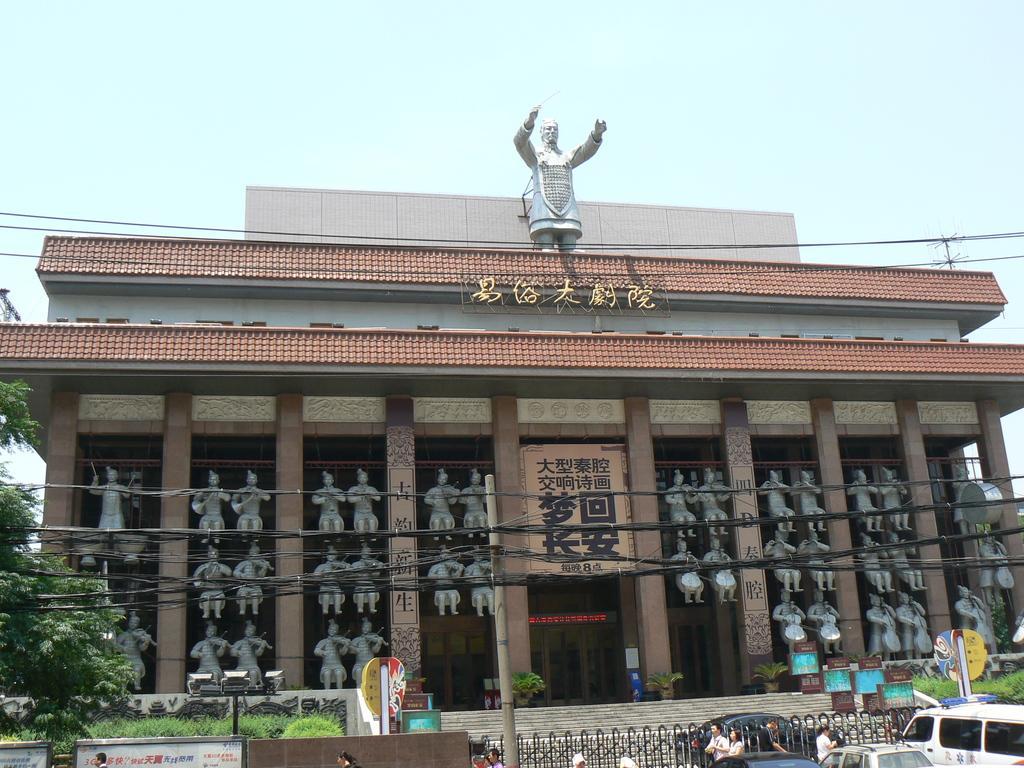Please provide a concise description of this image. As we can see in the image there is a building, banner, statues, trees, grass, few people here and there and fence. On the right side there are cars. On the top there is sky. 